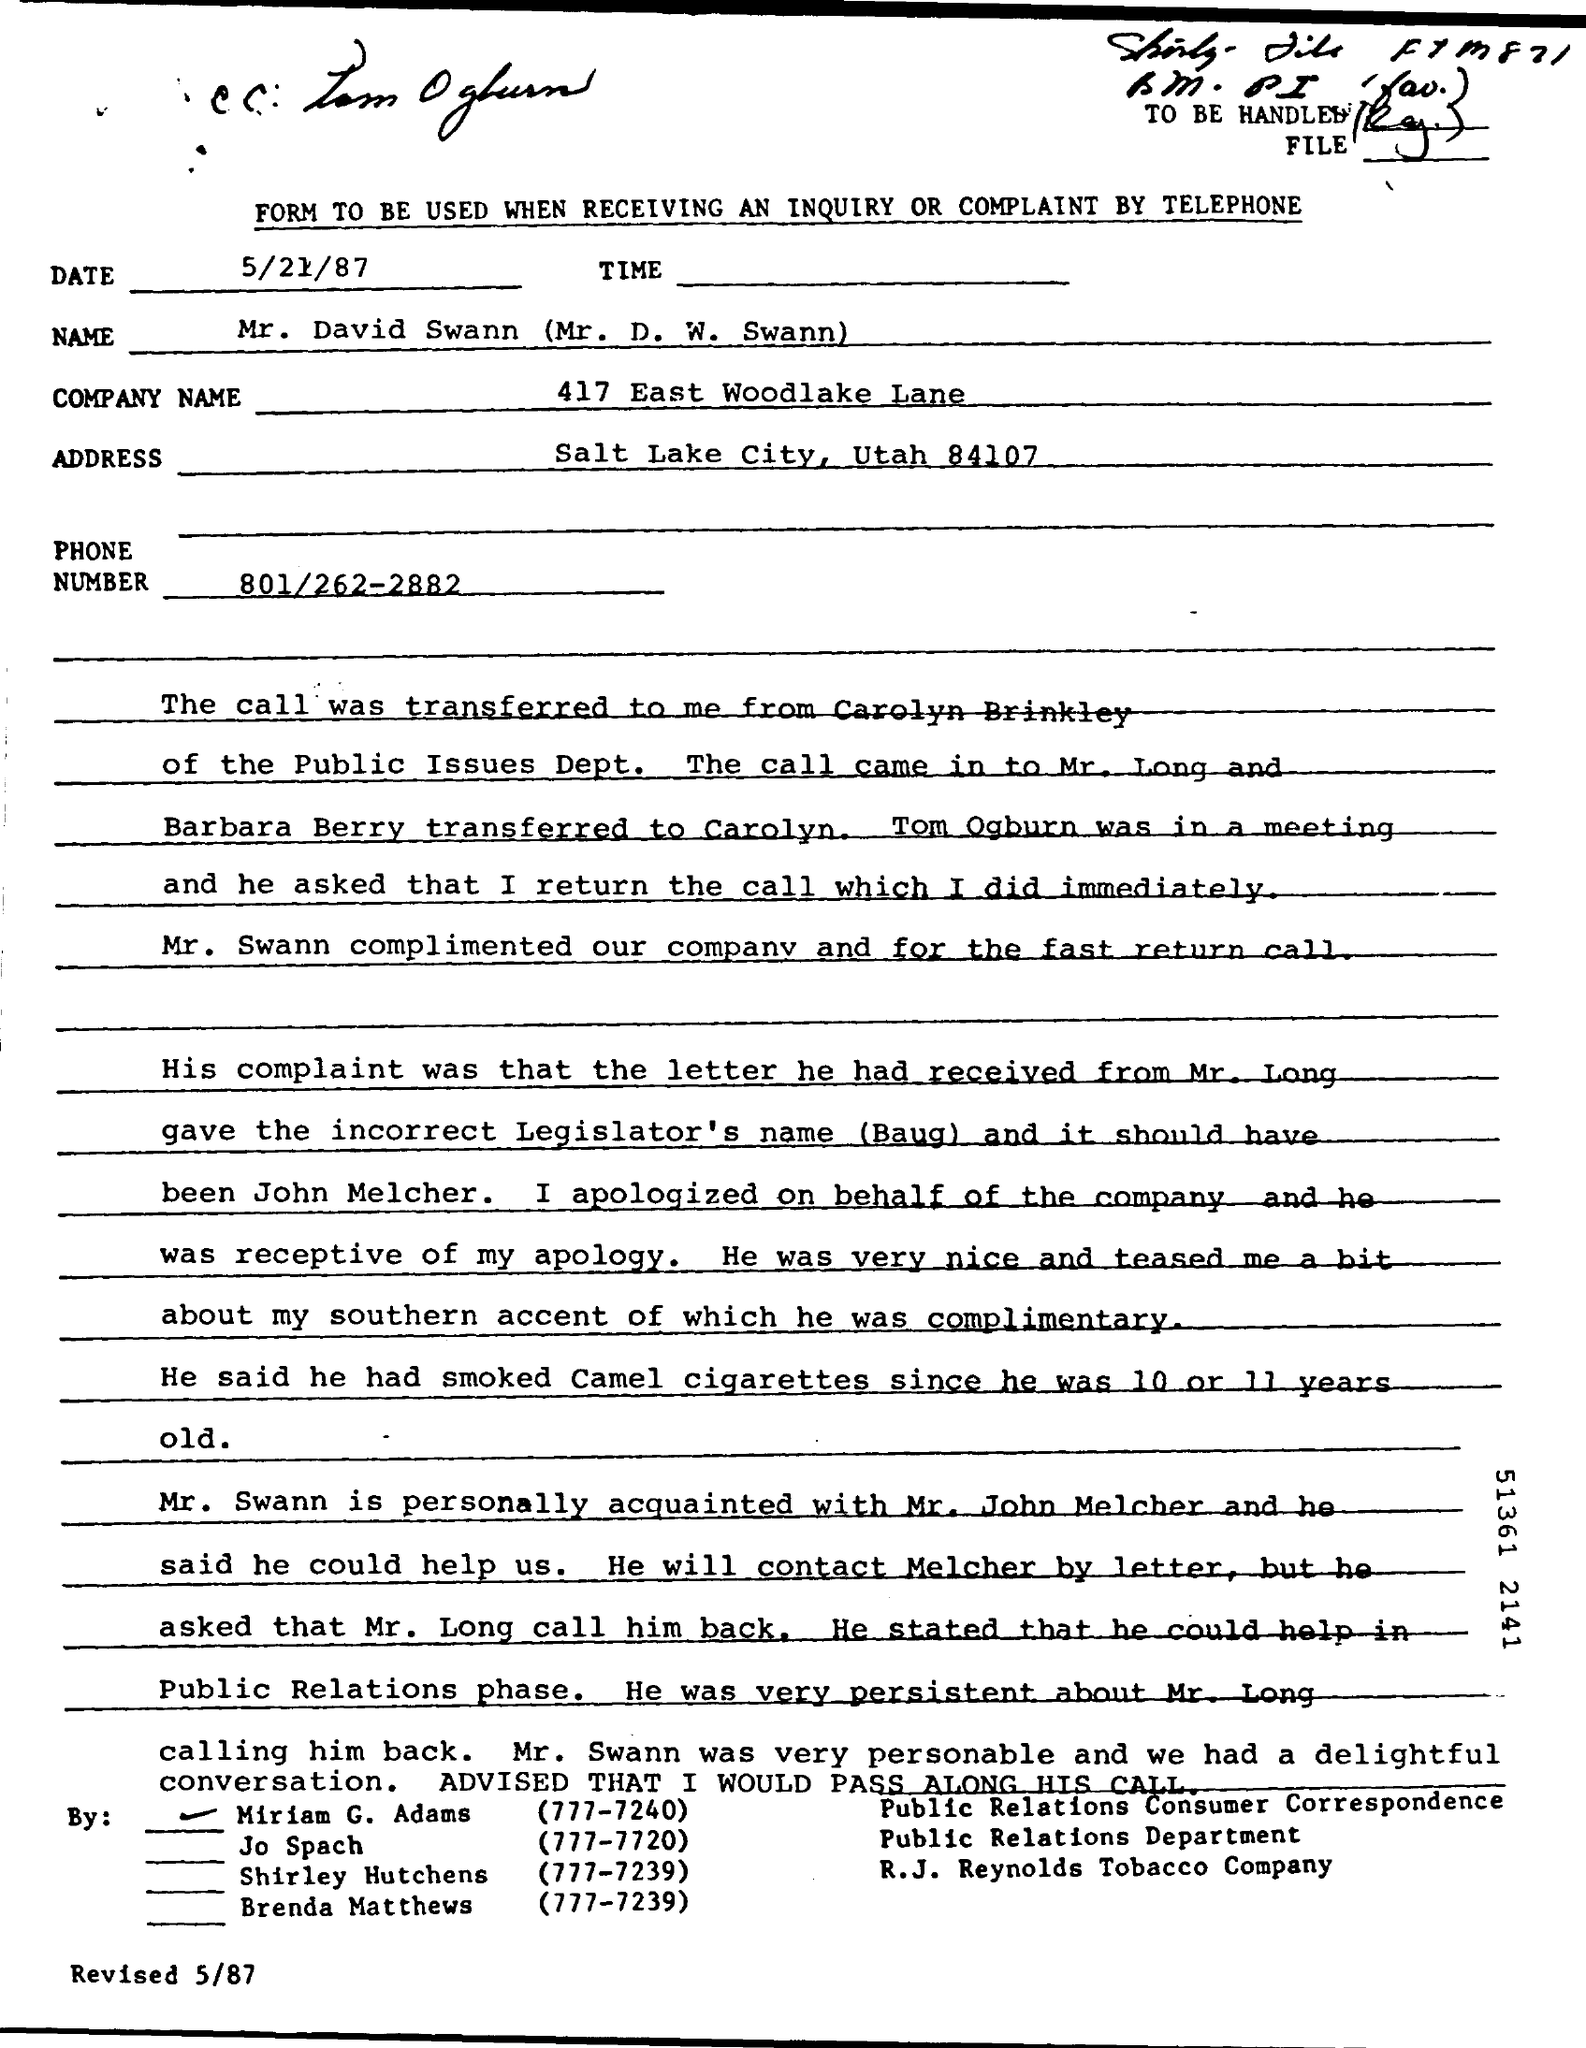Highlight a few significant elements in this photo. The memorandum address is located in Salt Lake City, Utah, specifically at 84107. The phone number is 801/262-2882. The Memorandum was dated on May 21, 1987. The Company Name is 417 East Woodlake Lane. 